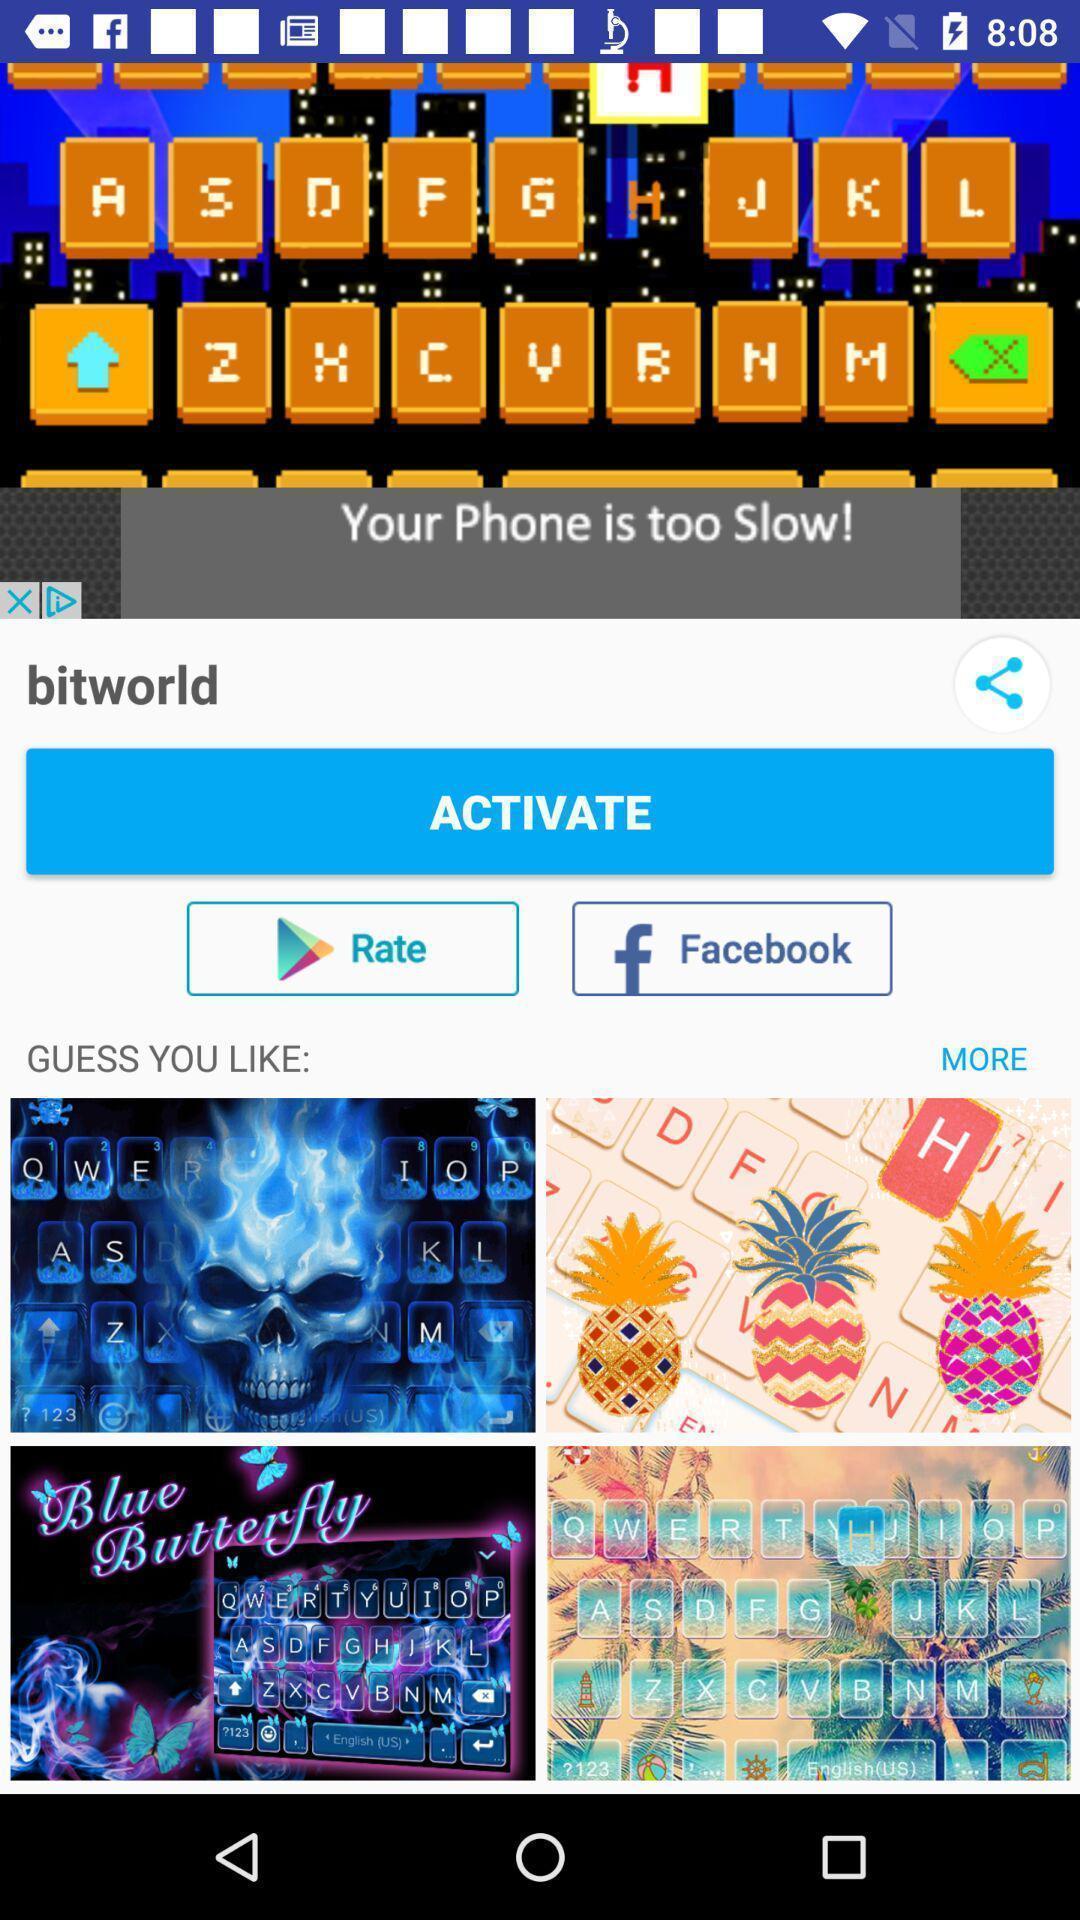Describe the visual elements of this screenshot. Pop of of your phone is too slow. 